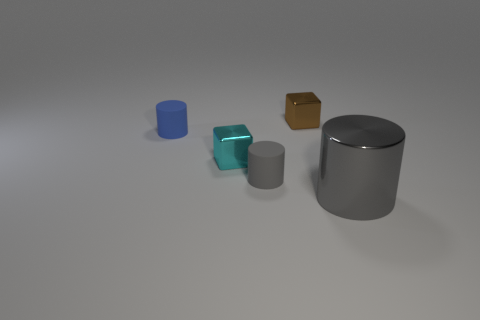There is another rubber object that is the same size as the gray rubber thing; what is its color?
Give a very brief answer. Blue. Are there any other things of the same color as the large cylinder?
Offer a terse response. Yes. There is a gray shiny object to the right of the blue matte object that is left of the block that is in front of the tiny brown metallic cube; what is its size?
Offer a very short reply. Large. There is a tiny thing that is on the right side of the cyan cube and in front of the small blue rubber thing; what is its color?
Make the answer very short. Gray. There is a gray shiny cylinder in front of the blue cylinder; how big is it?
Offer a terse response. Large. What number of large things have the same material as the small brown object?
Your response must be concise. 1. There is a object that is the same color as the shiny cylinder; what is its shape?
Your answer should be very brief. Cylinder. Do the metal object behind the tiny cyan metal block and the cyan thing have the same shape?
Give a very brief answer. Yes. There is another thing that is the same material as the small blue object; what is its color?
Provide a short and direct response. Gray. Are there any gray objects on the left side of the block that is behind the small blue cylinder that is to the left of the tiny gray cylinder?
Offer a terse response. Yes. 